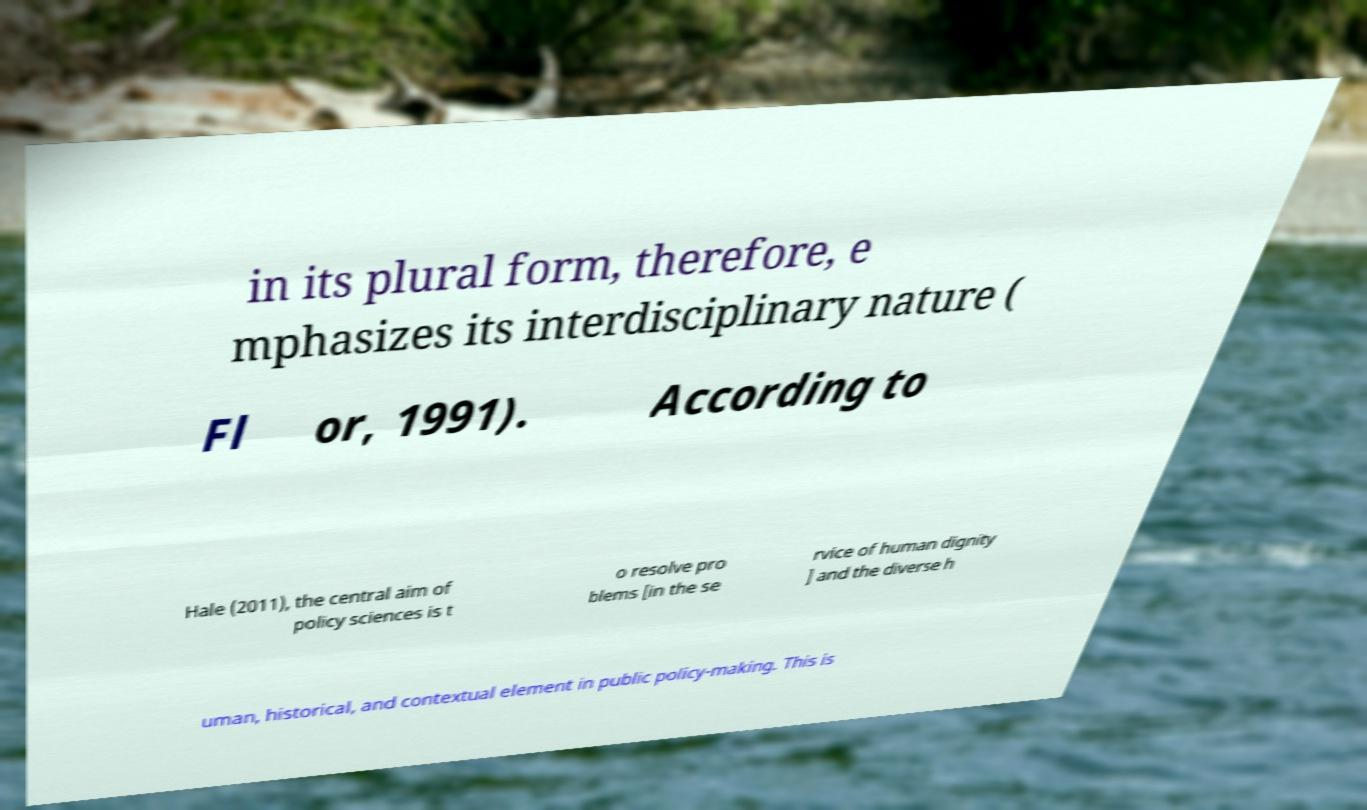Can you accurately transcribe the text from the provided image for me? in its plural form, therefore, e mphasizes its interdisciplinary nature ( Fl or, 1991). According to Hale (2011), the central aim of policy sciences is t o resolve pro blems [in the se rvice of human dignity ] and the diverse h uman, historical, and contextual element in public policy-making. This is 